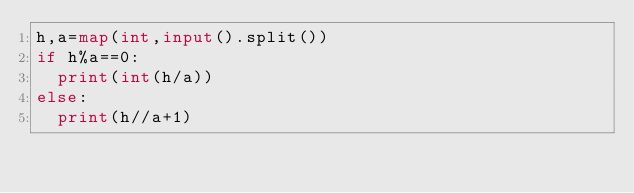Convert code to text. <code><loc_0><loc_0><loc_500><loc_500><_Python_>h,a=map(int,input().split())
if h%a==0:
  print(int(h/a))
else:
  print(h//a+1)</code> 